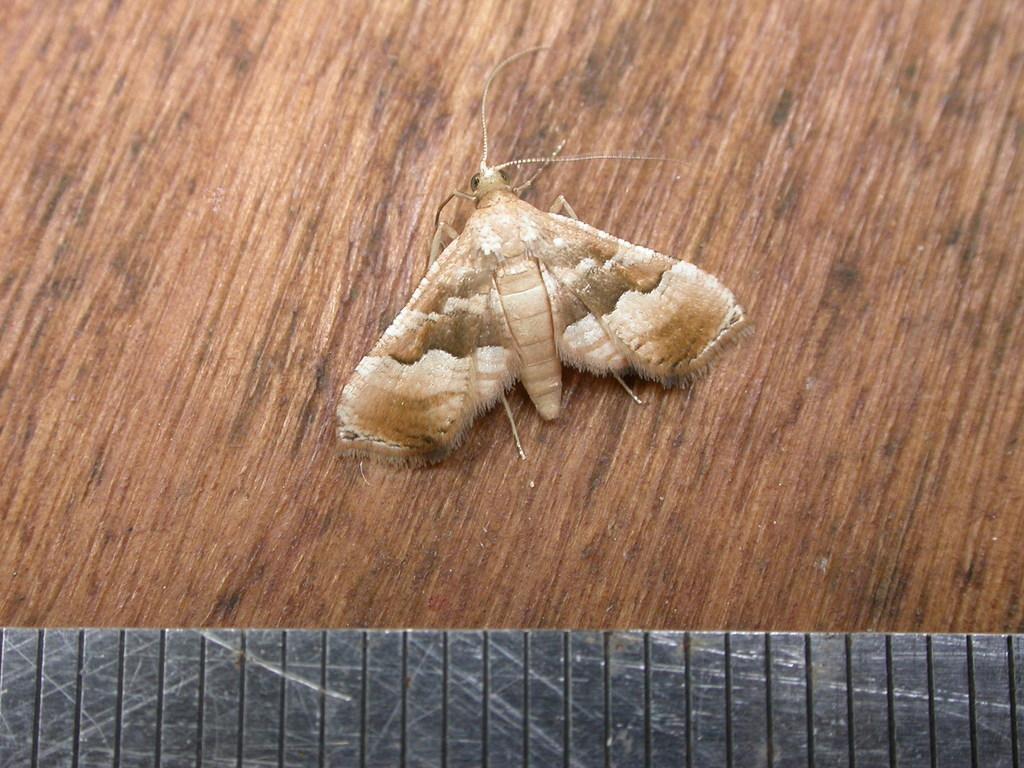Could you give a brief overview of what you see in this image? In this picture we can see an insect on the wooden object. Behind the insect it looks like an iron plate. 